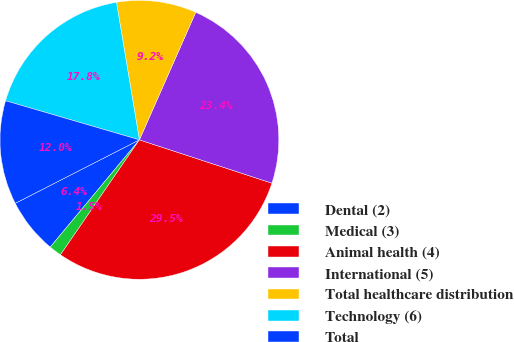<chart> <loc_0><loc_0><loc_500><loc_500><pie_chart><fcel>Dental (2)<fcel>Medical (3)<fcel>Animal health (4)<fcel>International (5)<fcel>Total healthcare distribution<fcel>Technology (6)<fcel>Total<nl><fcel>6.44%<fcel>1.46%<fcel>29.55%<fcel>23.41%<fcel>9.25%<fcel>17.85%<fcel>12.05%<nl></chart> 